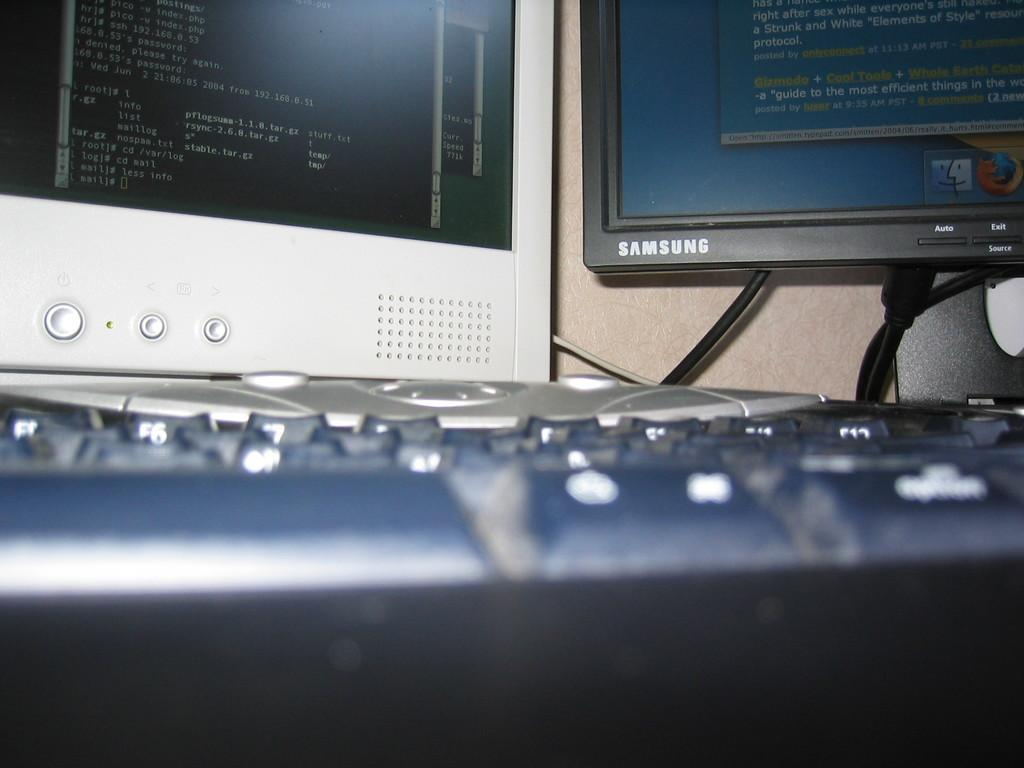<image>
Give a short and clear explanation of the subsequent image. The bottom half of two computer monitors, one white and one black, are visible with the white monitor displaying a password error message. 